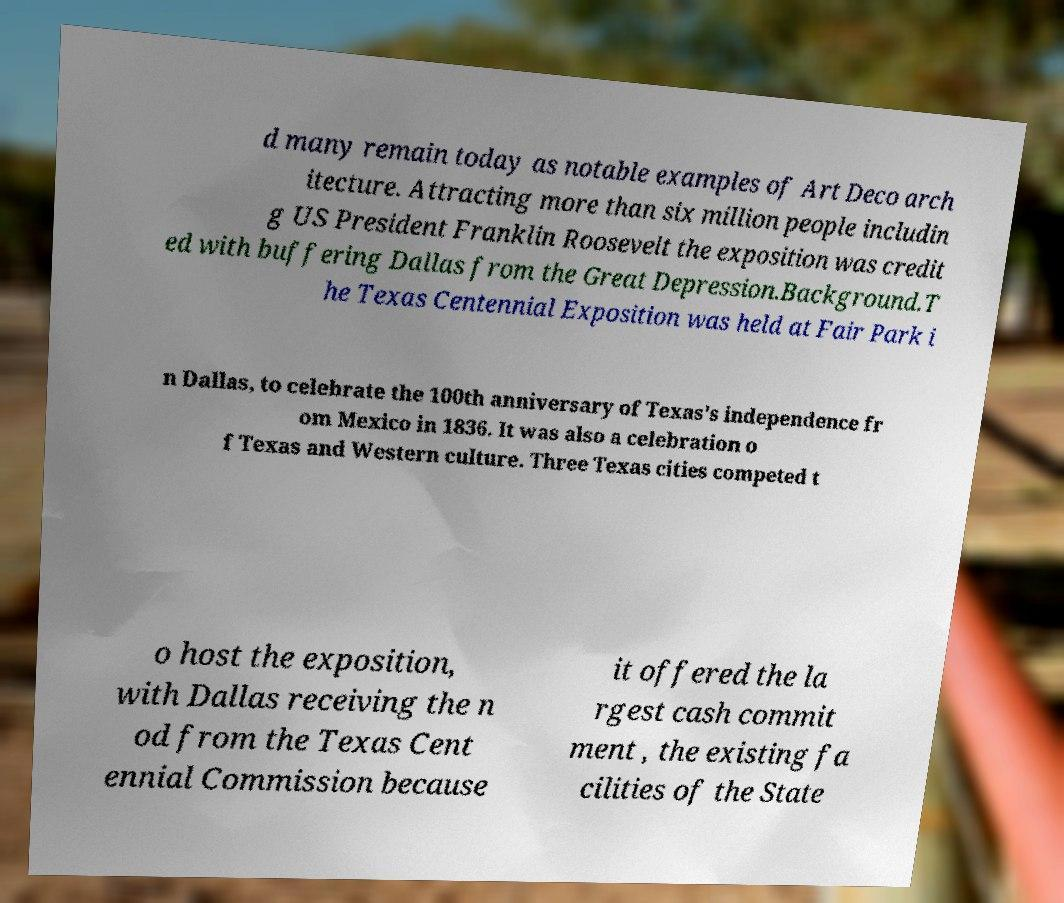Can you accurately transcribe the text from the provided image for me? d many remain today as notable examples of Art Deco arch itecture. Attracting more than six million people includin g US President Franklin Roosevelt the exposition was credit ed with buffering Dallas from the Great Depression.Background.T he Texas Centennial Exposition was held at Fair Park i n Dallas, to celebrate the 100th anniversary of Texas's independence fr om Mexico in 1836. It was also a celebration o f Texas and Western culture. Three Texas cities competed t o host the exposition, with Dallas receiving the n od from the Texas Cent ennial Commission because it offered the la rgest cash commit ment , the existing fa cilities of the State 